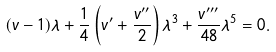<formula> <loc_0><loc_0><loc_500><loc_500>( v - 1 ) \lambda + \frac { 1 } { 4 } \left ( v ^ { \prime } + \frac { v ^ { \prime \prime } } { 2 } \right ) \lambda ^ { 3 } + \frac { v ^ { \prime \prime \prime } } { 4 8 } \lambda ^ { 5 } = 0 .</formula> 